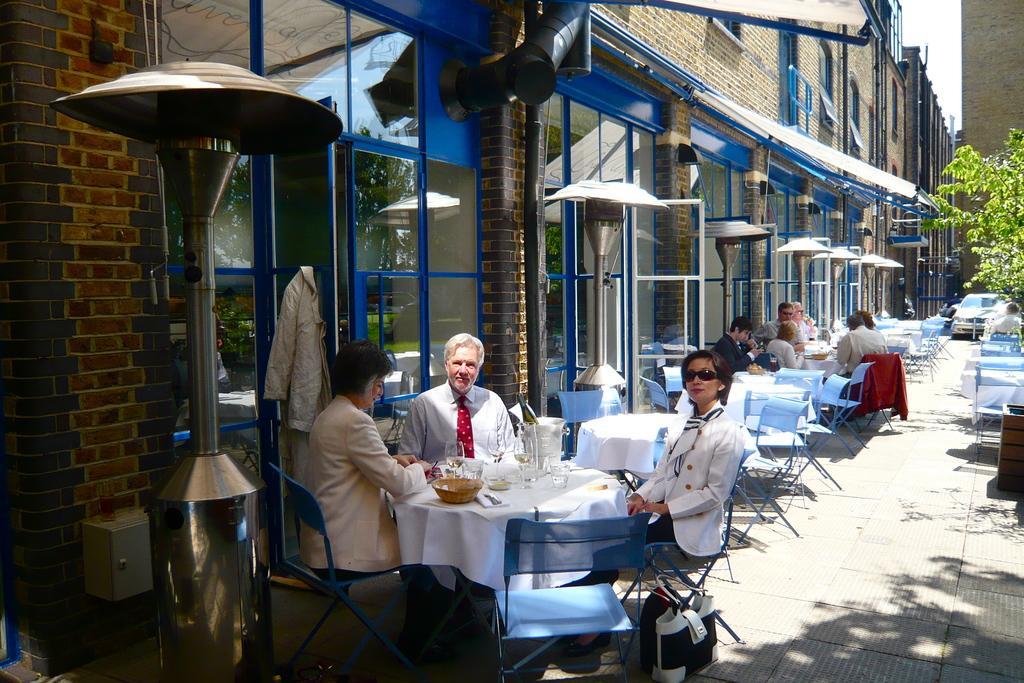How would you summarize this image in a sentence or two? In the image we can see there are lot of people sitting on chair and on table there are bowl, spoon, napkin and on the other side there is a building. 